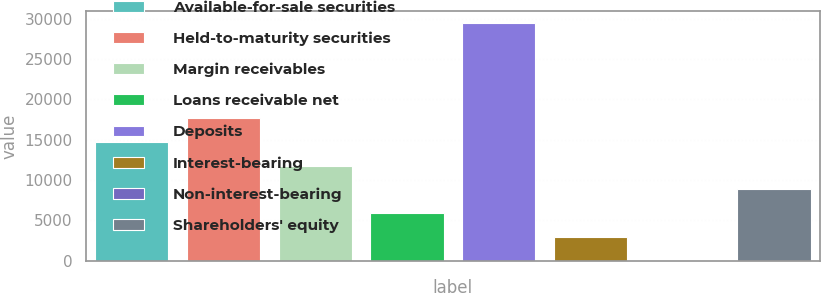Convert chart. <chart><loc_0><loc_0><loc_500><loc_500><bar_chart><fcel>Available-for-sale securities<fcel>Held-to-maturity securities<fcel>Margin receivables<fcel>Loans receivable net<fcel>Deposits<fcel>Interest-bearing<fcel>Non-interest-bearing<fcel>Shareholders' equity<nl><fcel>14726.5<fcel>17670.2<fcel>11782.8<fcel>5895.4<fcel>29445<fcel>2951.7<fcel>8<fcel>8839.1<nl></chart> 